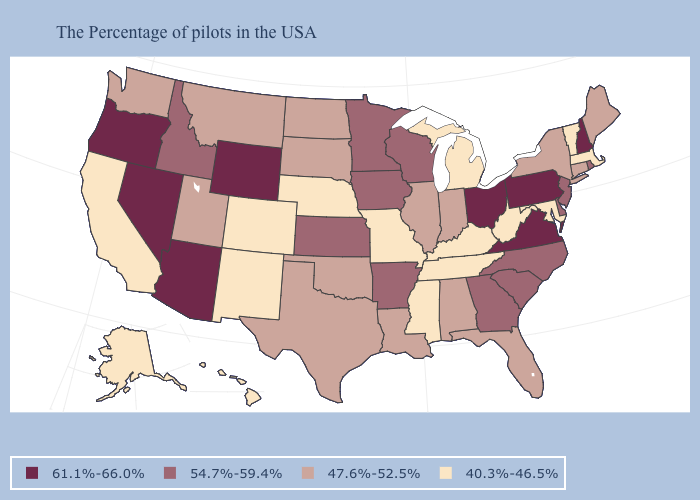Is the legend a continuous bar?
Short answer required. No. What is the value of Virginia?
Answer briefly. 61.1%-66.0%. Does New Mexico have the lowest value in the USA?
Give a very brief answer. Yes. Is the legend a continuous bar?
Concise answer only. No. Which states have the highest value in the USA?
Keep it brief. New Hampshire, Pennsylvania, Virginia, Ohio, Wyoming, Arizona, Nevada, Oregon. Which states have the highest value in the USA?
Answer briefly. New Hampshire, Pennsylvania, Virginia, Ohio, Wyoming, Arizona, Nevada, Oregon. Name the states that have a value in the range 61.1%-66.0%?
Short answer required. New Hampshire, Pennsylvania, Virginia, Ohio, Wyoming, Arizona, Nevada, Oregon. Name the states that have a value in the range 54.7%-59.4%?
Short answer required. Rhode Island, New Jersey, Delaware, North Carolina, South Carolina, Georgia, Wisconsin, Arkansas, Minnesota, Iowa, Kansas, Idaho. Does the map have missing data?
Be succinct. No. Name the states that have a value in the range 40.3%-46.5%?
Quick response, please. Massachusetts, Vermont, Maryland, West Virginia, Michigan, Kentucky, Tennessee, Mississippi, Missouri, Nebraska, Colorado, New Mexico, California, Alaska, Hawaii. Among the states that border Nebraska , which have the lowest value?
Keep it brief. Missouri, Colorado. Does West Virginia have the lowest value in the USA?
Be succinct. Yes. Name the states that have a value in the range 40.3%-46.5%?
Quick response, please. Massachusetts, Vermont, Maryland, West Virginia, Michigan, Kentucky, Tennessee, Mississippi, Missouri, Nebraska, Colorado, New Mexico, California, Alaska, Hawaii. Name the states that have a value in the range 61.1%-66.0%?
Short answer required. New Hampshire, Pennsylvania, Virginia, Ohio, Wyoming, Arizona, Nevada, Oregon. Does Arkansas have a lower value than Washington?
Keep it brief. No. 